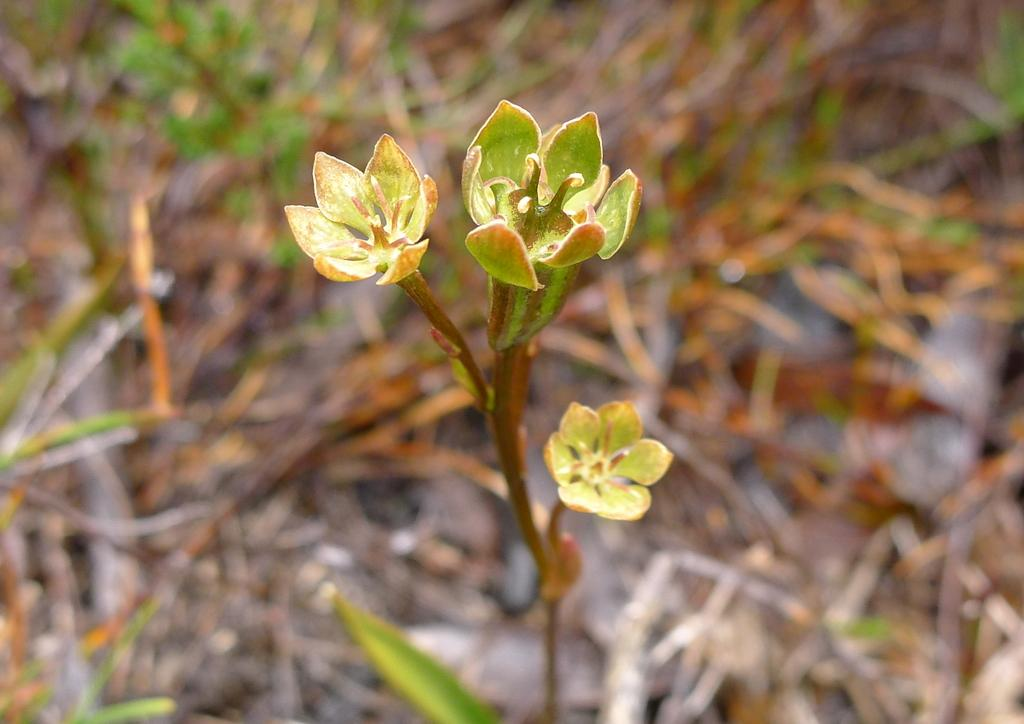Where was the image taken? The image was taken outdoors. What can be seen in the background of the image? There are plants in the background of the image. What is the main subject of the image? There is a plant with three flowers in the middle of the image. What type of bun is being used to hold the flowers together in the image? There is no bun present in the image; the flowers are attached to the plant naturally. 